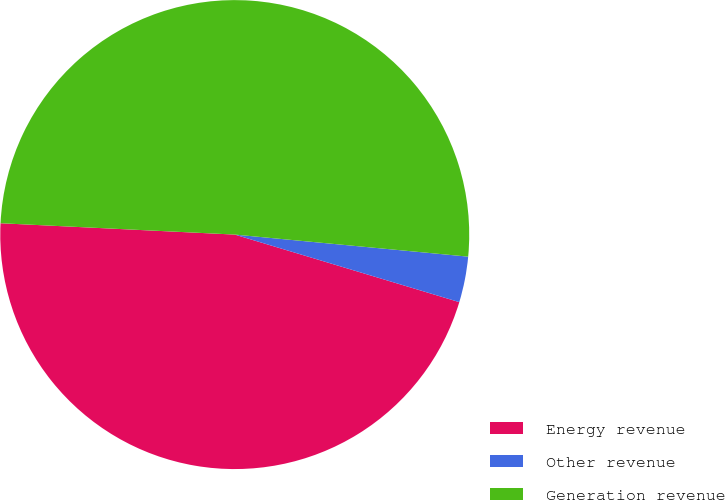Convert chart to OTSL. <chart><loc_0><loc_0><loc_500><loc_500><pie_chart><fcel>Energy revenue<fcel>Other revenue<fcel>Generation revenue<nl><fcel>46.12%<fcel>3.15%<fcel>50.73%<nl></chart> 